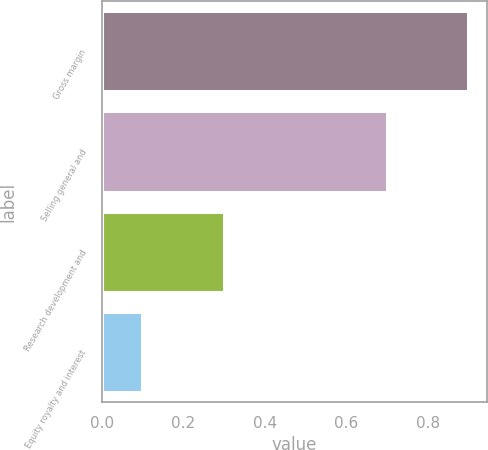<chart> <loc_0><loc_0><loc_500><loc_500><bar_chart><fcel>Gross margin<fcel>Selling general and<fcel>Research development and<fcel>Equity royalty and interest<nl><fcel>0.9<fcel>0.7<fcel>0.3<fcel>0.1<nl></chart> 